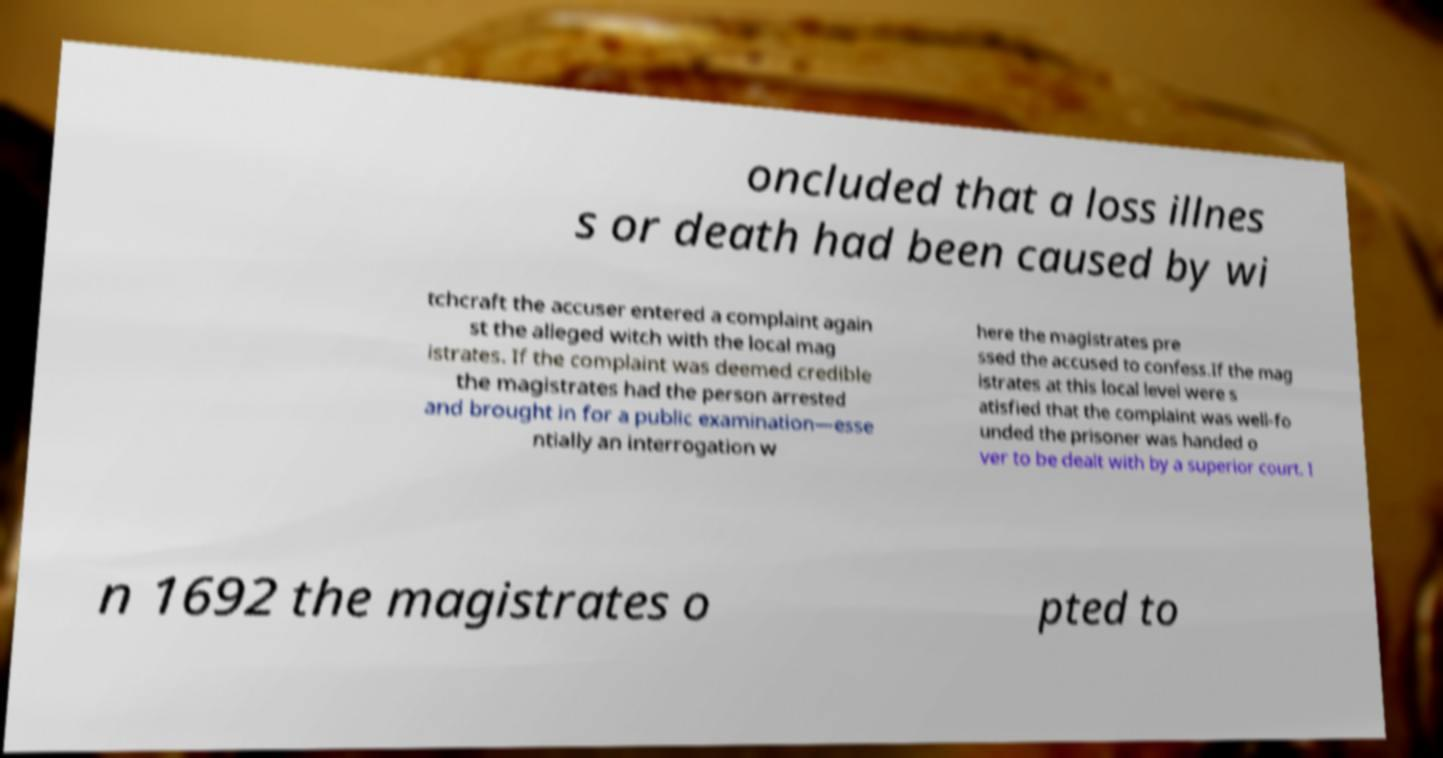Could you assist in decoding the text presented in this image and type it out clearly? oncluded that a loss illnes s or death had been caused by wi tchcraft the accuser entered a complaint again st the alleged witch with the local mag istrates. If the complaint was deemed credible the magistrates had the person arrested and brought in for a public examination—esse ntially an interrogation w here the magistrates pre ssed the accused to confess.If the mag istrates at this local level were s atisfied that the complaint was well-fo unded the prisoner was handed o ver to be dealt with by a superior court. I n 1692 the magistrates o pted to 